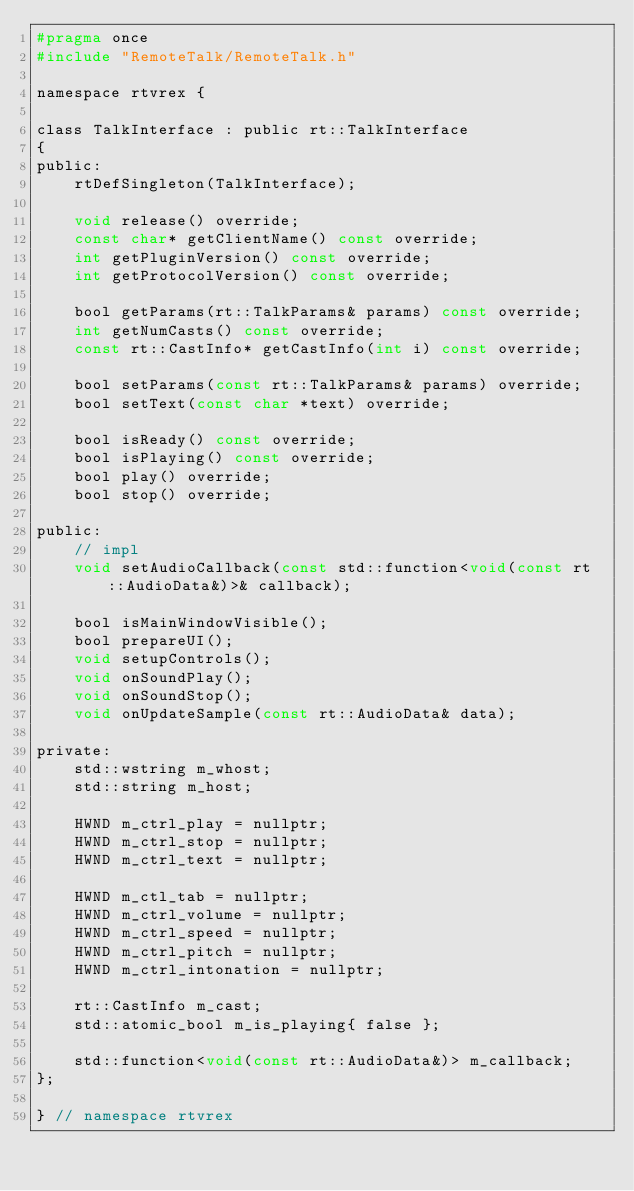<code> <loc_0><loc_0><loc_500><loc_500><_C_>#pragma once
#include "RemoteTalk/RemoteTalk.h"

namespace rtvrex {

class TalkInterface : public rt::TalkInterface
{
public:
    rtDefSingleton(TalkInterface);

    void release() override;
    const char* getClientName() const override;
    int getPluginVersion() const override;
    int getProtocolVersion() const override;

    bool getParams(rt::TalkParams& params) const override;
    int getNumCasts() const override;
    const rt::CastInfo* getCastInfo(int i) const override;

    bool setParams(const rt::TalkParams& params) override;
    bool setText(const char *text) override;

    bool isReady() const override;
    bool isPlaying() const override;
    bool play() override;
    bool stop() override;

public:
    // impl
    void setAudioCallback(const std::function<void(const rt::AudioData&)>& callback);

    bool isMainWindowVisible();
    bool prepareUI();
    void setupControls();
    void onSoundPlay();
    void onSoundStop();
    void onUpdateSample(const rt::AudioData& data);

private:
    std::wstring m_whost;
    std::string m_host;

    HWND m_ctrl_play = nullptr;
    HWND m_ctrl_stop = nullptr;
    HWND m_ctrl_text = nullptr;

    HWND m_ctl_tab = nullptr;
    HWND m_ctrl_volume = nullptr;
    HWND m_ctrl_speed = nullptr;
    HWND m_ctrl_pitch = nullptr;
    HWND m_ctrl_intonation = nullptr;

    rt::CastInfo m_cast;
    std::atomic_bool m_is_playing{ false };

    std::function<void(const rt::AudioData&)> m_callback;
};

} // namespace rtvrex
</code> 